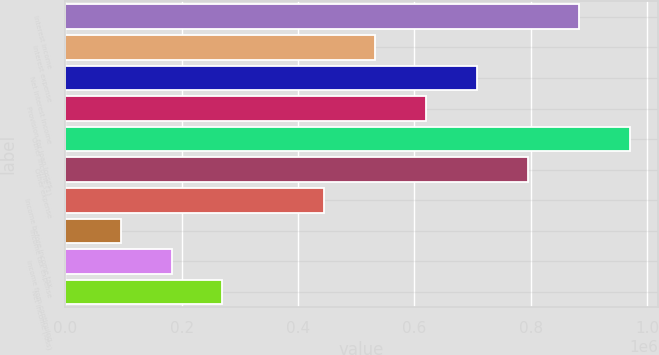Convert chart. <chart><loc_0><loc_0><loc_500><loc_500><bar_chart><fcel>Interest income<fcel>Interest expense<fcel>Net interest income<fcel>Provision for loan losses<fcel>Other income (1)<fcel>Other expense<fcel>Income before income tax<fcel>Income tax expense<fcel>Income from continuing<fcel>Net income (loss)<nl><fcel>882494<fcel>532445<fcel>707469<fcel>619957<fcel>970006<fcel>794981<fcel>444933<fcel>94885<fcel>182397<fcel>269909<nl></chart> 